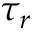Convert formula to latex. <formula><loc_0><loc_0><loc_500><loc_500>\tau _ { r }</formula> 